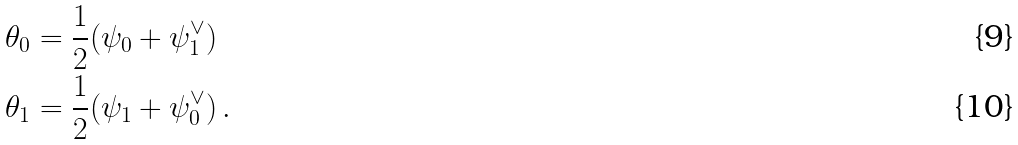Convert formula to latex. <formula><loc_0><loc_0><loc_500><loc_500>\theta _ { 0 } & = { \frac { 1 } { 2 } } ( \psi _ { 0 } + \psi _ { 1 } ^ { \vee } ) \\ \theta _ { 1 } & = { \frac { 1 } { 2 } } ( \psi _ { 1 } + \psi _ { 0 } ^ { \vee } ) \, .</formula> 